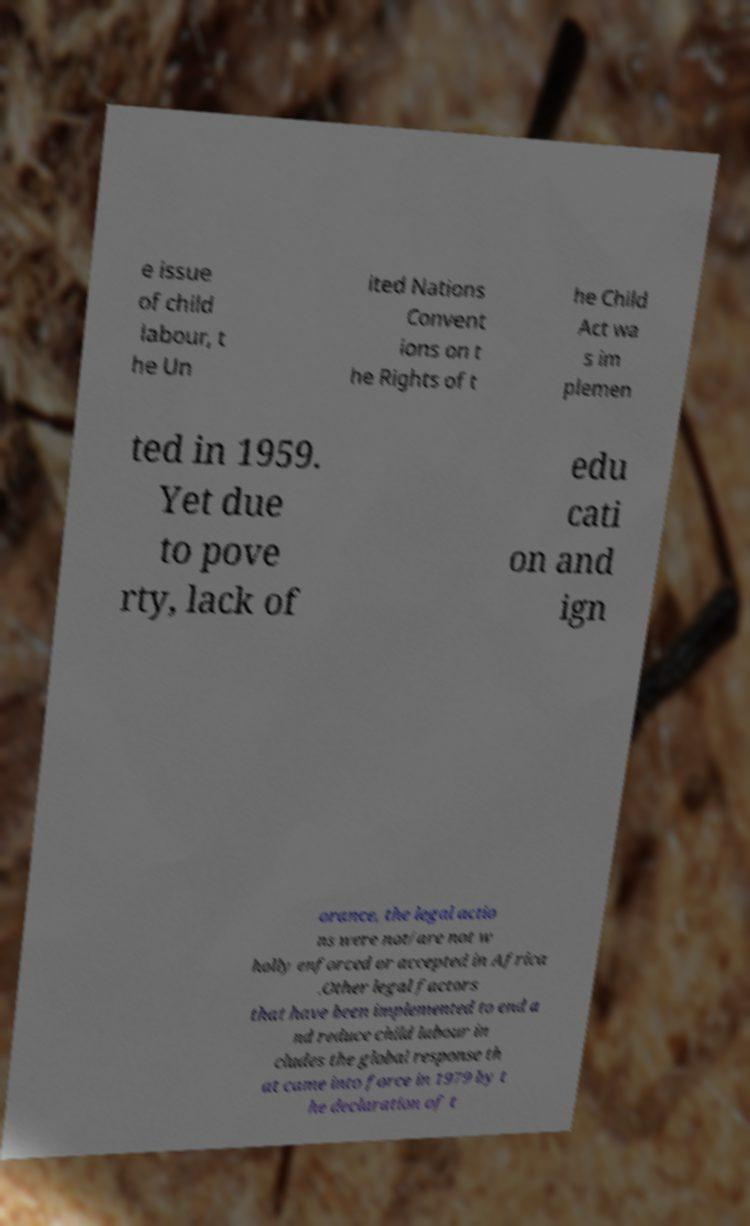Can you read and provide the text displayed in the image?This photo seems to have some interesting text. Can you extract and type it out for me? e issue of child labour, t he Un ited Nations Convent ions on t he Rights of t he Child Act wa s im plemen ted in 1959. Yet due to pove rty, lack of edu cati on and ign orance, the legal actio ns were not/are not w holly enforced or accepted in Africa .Other legal factors that have been implemented to end a nd reduce child labour in cludes the global response th at came into force in 1979 by t he declaration of t 